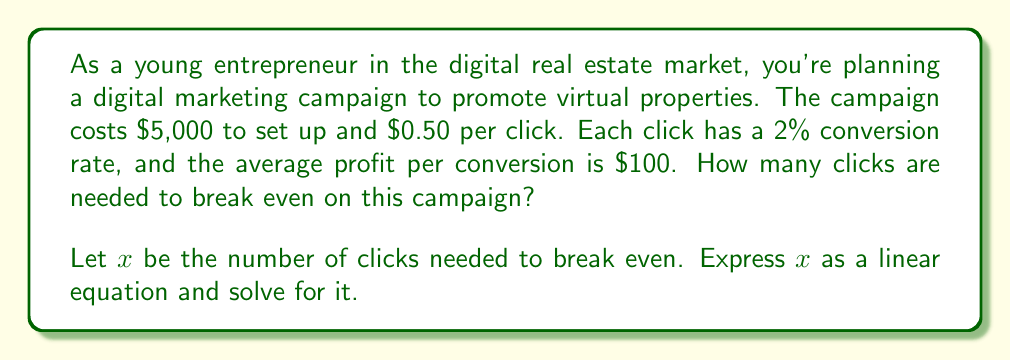What is the answer to this math problem? Let's approach this step-by-step:

1) First, let's define our variables:
   $x$ = number of clicks
   $y$ = total revenue

2) Now, let's set up our revenue equation:
   Revenue = (Number of clicks) × (Conversion rate) × (Profit per conversion)
   $y = x \times 0.02 \times $100 = 2x$

3) Next, let's set up our cost equation:
   Cost = Setup cost + (Cost per click × Number of clicks)
   $C = 5000 + 0.50x$

4) At the break-even point, revenue equals cost:
   $y = C$
   $2x = 5000 + 0.50x$

5) Now we have our linear equation. Let's solve for $x$:
   $2x = 5000 + 0.50x$
   $2x - 0.50x = 5000$
   $1.50x = 5000$

6) Divide both sides by 1.50:
   $x = \frac{5000}{1.50} = 3333.33$

7) Since we can't have a fractional number of clicks, we round up to the nearest whole number.
Answer: The break-even point is 3,334 clicks. 